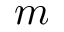<formula> <loc_0><loc_0><loc_500><loc_500>m</formula> 